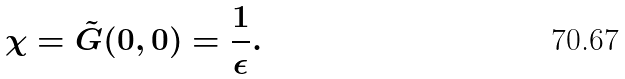Convert formula to latex. <formula><loc_0><loc_0><loc_500><loc_500>\chi = \tilde { G } ( 0 , 0 ) = \frac { 1 } { \epsilon } .</formula> 